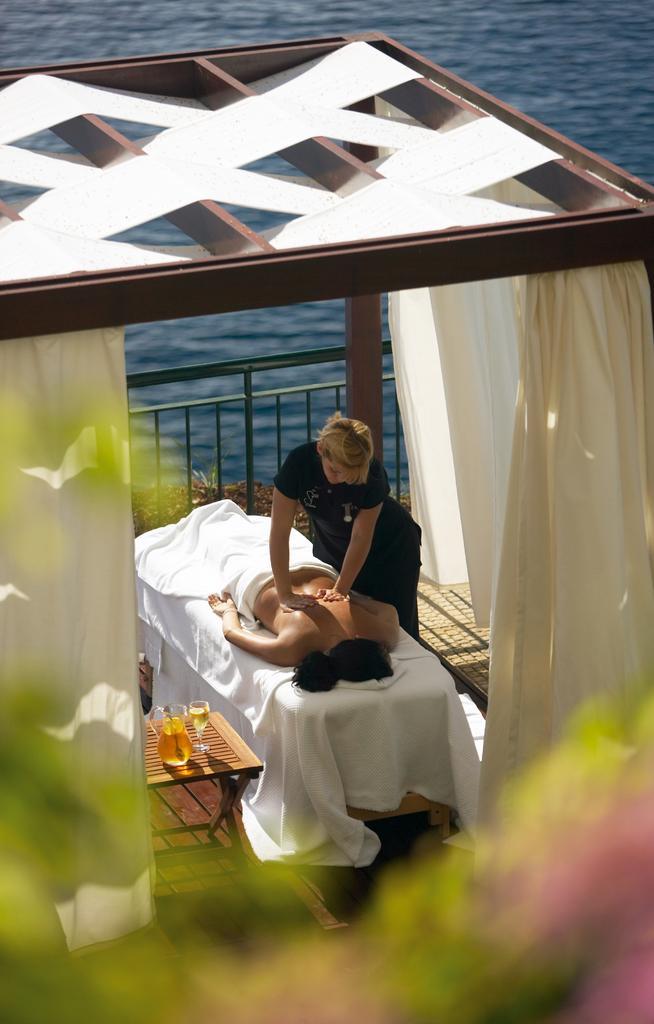Describe this image in one or two sentences. In the middle of this image, there is a woman in a black color dress, placing both hands on the back side of a person who is lying on a bed and is partially covered with a white color cloth. Beside this bed, there are a jug and a glass placed on a wooden stool. These two persons under a shelter which is having white color curtains. At the bottom of this image, there is an object. In the background, there is a fence and there is water. 